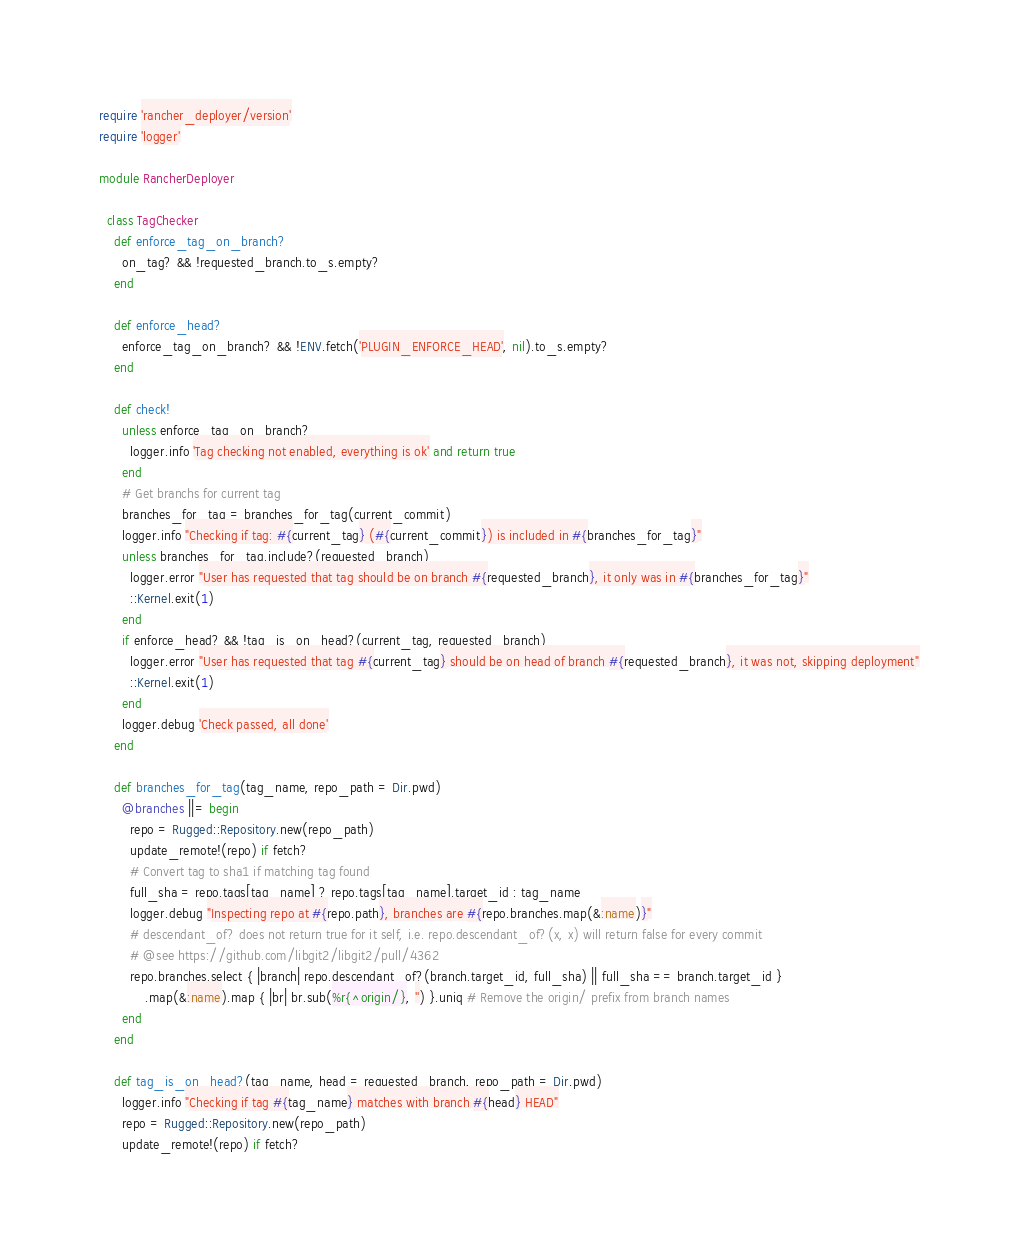Convert code to text. <code><loc_0><loc_0><loc_500><loc_500><_Ruby_>require 'rancher_deployer/version'
require 'logger'

module RancherDeployer

  class TagChecker
    def enforce_tag_on_branch?
      on_tag? && !requested_branch.to_s.empty?
    end

    def enforce_head?
      enforce_tag_on_branch? && !ENV.fetch('PLUGIN_ENFORCE_HEAD', nil).to_s.empty?
    end

    def check!
      unless enforce_tag_on_branch?
        logger.info 'Tag checking not enabled, everything is ok' and return true
      end
      # Get branchs for current tag
      branches_for_tag = branches_for_tag(current_commit)
      logger.info "Checking if tag: #{current_tag} (#{current_commit}) is included in #{branches_for_tag}"
      unless branches_for_tag.include?(requested_branch)
        logger.error "User has requested that tag should be on branch #{requested_branch}, it only was in #{branches_for_tag}"
        ::Kernel.exit(1)
      end
      if enforce_head? && !tag_is_on_head?(current_tag, requested_branch)
        logger.error "User has requested that tag #{current_tag} should be on head of branch #{requested_branch}, it was not, skipping deployment"
        ::Kernel.exit(1)
      end
      logger.debug 'Check passed, all done'
    end

    def branches_for_tag(tag_name, repo_path = Dir.pwd)
      @branches ||= begin
        repo = Rugged::Repository.new(repo_path)
        update_remote!(repo) if fetch?
        # Convert tag to sha1 if matching tag found
        full_sha = repo.tags[tag_name] ? repo.tags[tag_name].target_id : tag_name
        logger.debug "Inspecting repo at #{repo.path}, branches are #{repo.branches.map(&:name)}"
        # descendant_of? does not return true for it self, i.e. repo.descendant_of?(x, x) will return false for every commit
        # @see https://github.com/libgit2/libgit2/pull/4362
        repo.branches.select { |branch| repo.descendant_of?(branch.target_id, full_sha) || full_sha == branch.target_id }
            .map(&:name).map { |br| br.sub(%r{^origin/}, '') }.uniq # Remove the origin/ prefix from branch names
      end
    end

    def tag_is_on_head?(tag_name, head = requested_branch, repo_path = Dir.pwd)
      logger.info "Checking if tag #{tag_name} matches with branch #{head} HEAD"
      repo = Rugged::Repository.new(repo_path)
      update_remote!(repo) if fetch?</code> 